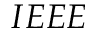Convert formula to latex. <formula><loc_0><loc_0><loc_500><loc_500>I E E E</formula> 